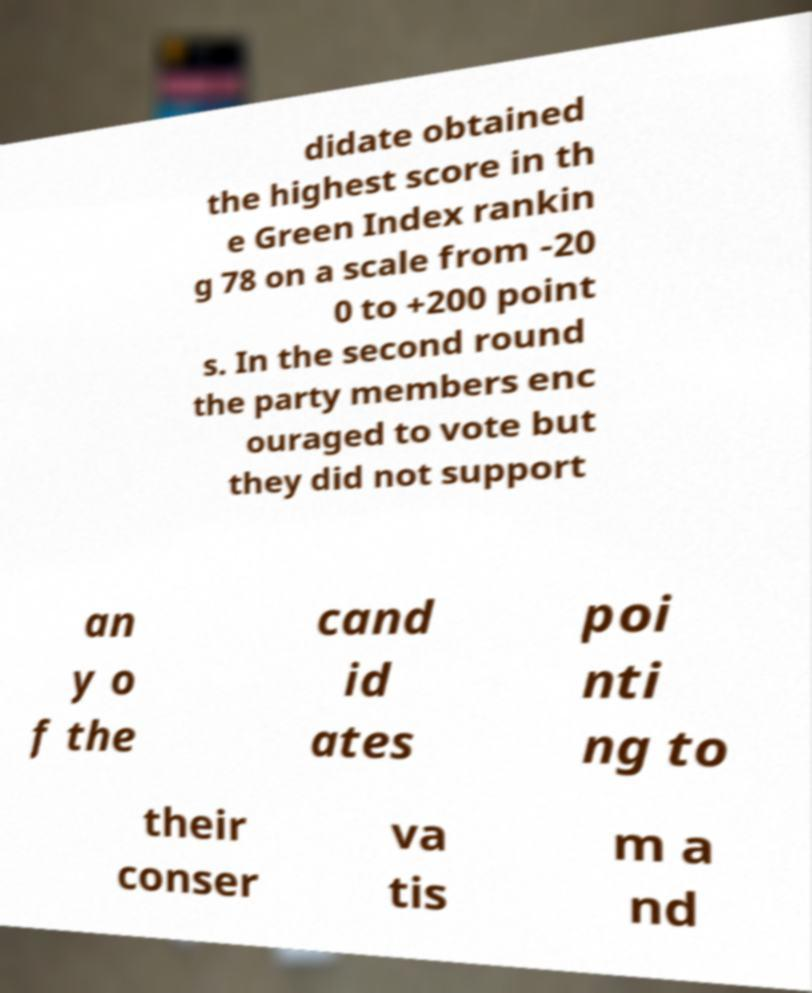Please read and relay the text visible in this image. What does it say? didate obtained the highest score in th e Green Index rankin g 78 on a scale from -20 0 to +200 point s. In the second round the party members enc ouraged to vote but they did not support an y o f the cand id ates poi nti ng to their conser va tis m a nd 